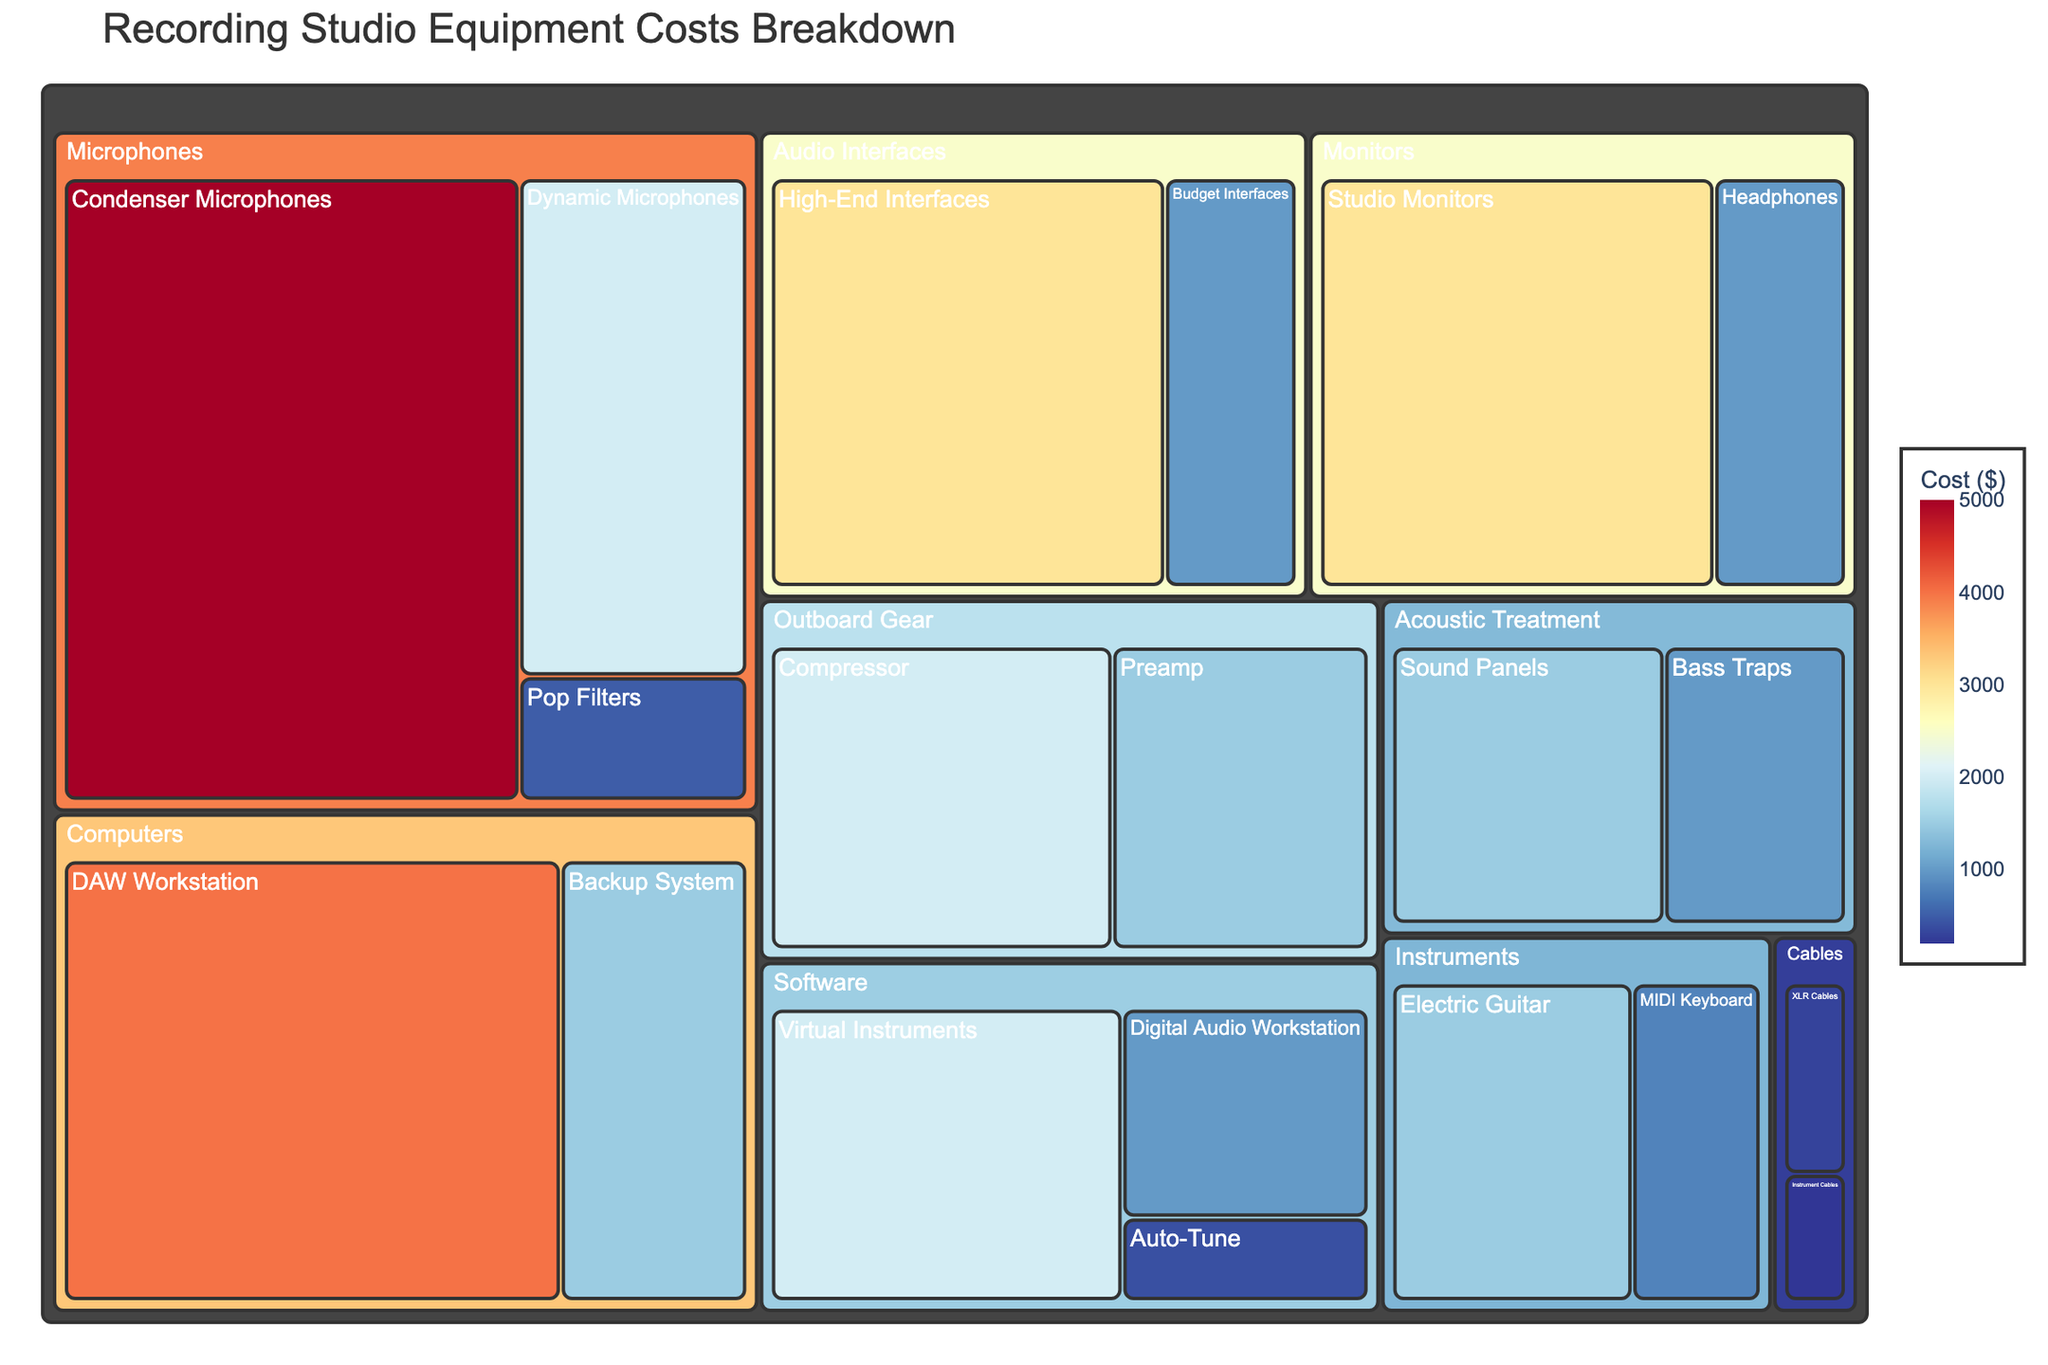What is the total cost of the microphones category? To find the total cost for the microphones category, sum the costs of its subcategories: Condenser Microphones ($5000), Dynamic Microphones ($2000), and Pop Filters ($500). 5000 + 2000 + 500 = 7500.
Answer: 7500 Which category has the highest individual equipment cost, and what is that cost? Look for the highest single value across all categories in the figure. The most expensive individual piece of equipment is the Condenser Microphones in the Microphones category with a cost of $5000.
Answer: Microphones, $5000 How does the cost of the high-end interfaces compare to budget interfaces under audio interfaces? Compare the costs of high-end interfaces ($3000) with budget interfaces ($1000) by calculating the difference: 3000 - 1000 = 2000, so high-end interfaces cost $2000 more.
Answer: High-End Interfaces are $2000 more expensive What's the average cost of the equipment under the software category? To calculate the average cost under software, sum the costs: Digital Audio Workstation ($1000), Auto-Tune ($400), Virtual Instruments ($2000) giving 1000 + 400 + 2000 = 3400. Then, divide by the number of items (3): 3400 / 3 ≈ 1133.33
Answer: 1133.33 Which category includes the most subcategories, and how many does it have? Count the number of subcategories for each category. The 'Microphones' and 'Software' categories have 3 subcategories each.
Answer: Microphones, Software (3 each) What percentage of the total cost is spent on computers? First, calculate the total cost of all equipment (sum of all costs): $5000 + $2000 + $500 + $3000 + $1000 + $4000 + $1500 + $1000 + $400 + $2000 + $3000 + $1000 + $1500 + $1000 + $800 + $1500 + $2000 + $1500 + $300 + $200 = $33900. Then, calculate the total for computers: DAW Workstation ($4000) and Backup System ($1500) sum to 4000 + 1500 = 5500. Finally, calculate the percentage: (5500 / 33900) * 100 ≈ 16.22%
Answer: 16.22% Which is more expensive: Studio Monitors or Electric Guitar, and by how much? Compare the costs of Studio Monitors ($3000) and Electric Guitar ($1500). The difference is 3000 - 1500 = 1500, so Studio Monitors are $1500 more expensive.
Answer: Studio Monitors, $1500 What is the ratio of the cost of Acoustic Treatment to the cost of Outboard Gear? First, find the total costs: Acoustic Treatment (Sound Panels $1500 + Bass Traps $1000) = $2500, and Outboard Gear (Compressor $2000 + Preamp $1500) = $3500. Calculate the ratio: 2500 / 3500 = 5 / 7 or approximately 0.71.
Answer: 0.71 Identify the least expensive piece of equipment and its cost. Find the lowest cost across all subcategories in the figure. The least expensive piece is Instrument Cables at $200.
Answer: Instrument Cables, $200 